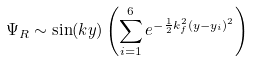<formula> <loc_0><loc_0><loc_500><loc_500>\Psi _ { R } \sim \sin ( k y ) \left ( \sum _ { i = 1 } ^ { 6 } e ^ { - \frac { 1 } { 2 } k _ { f } ^ { 2 } ( y - y _ { i } ) ^ { 2 } } \right )</formula> 